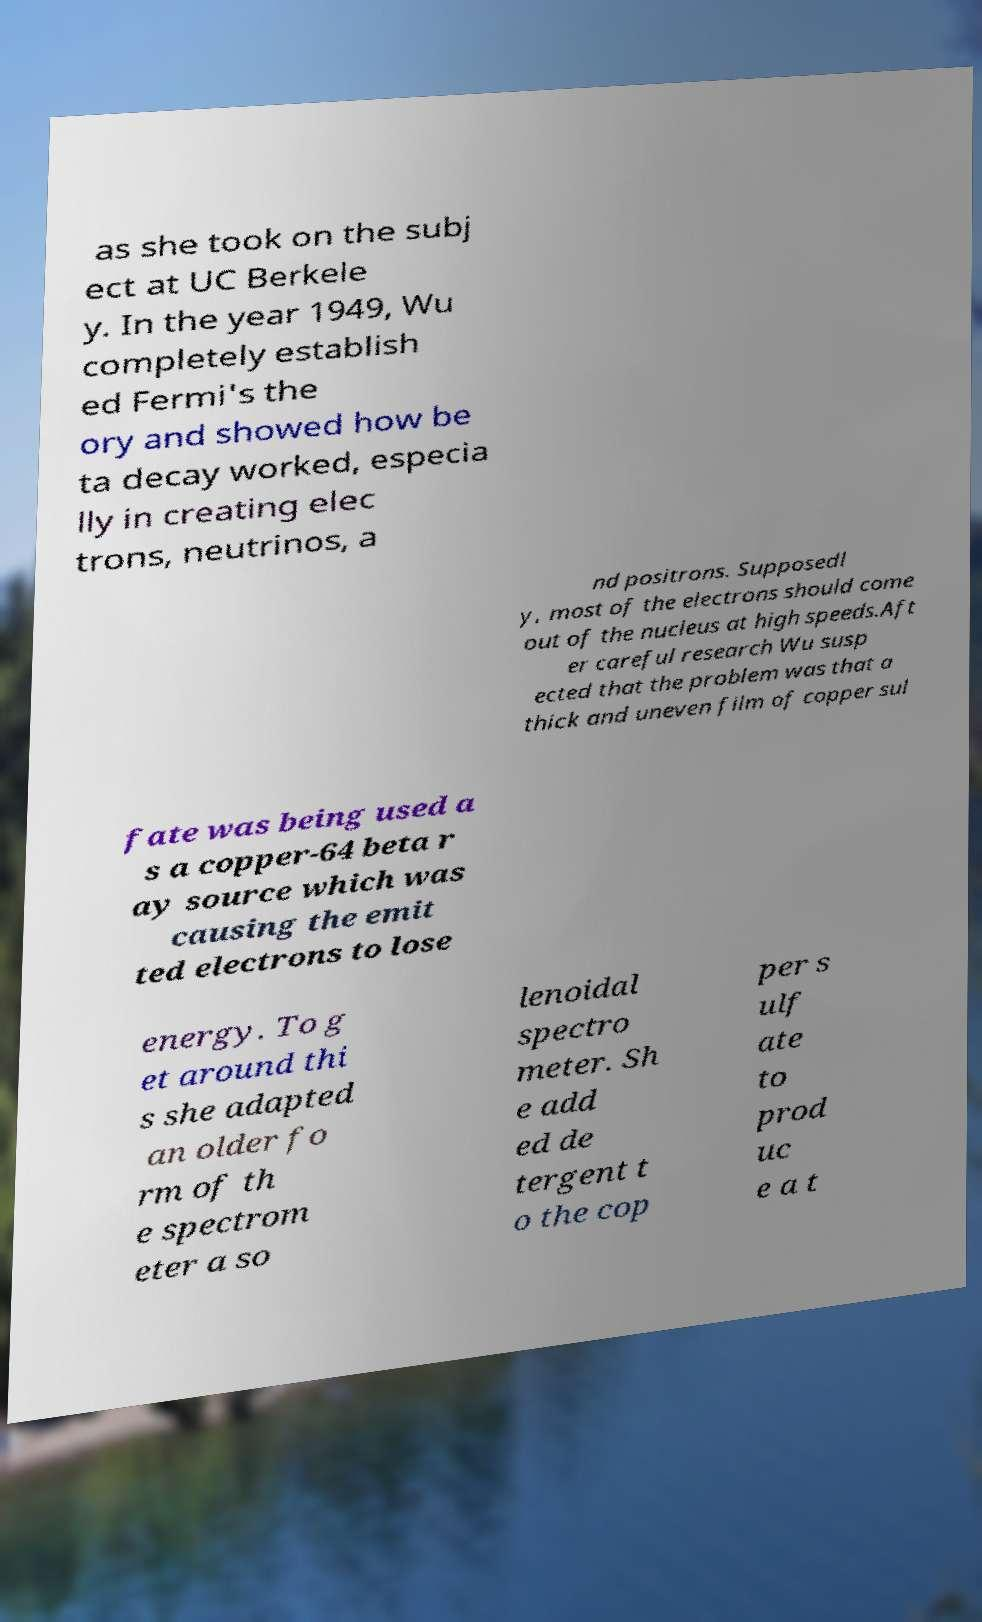Could you assist in decoding the text presented in this image and type it out clearly? as she took on the subj ect at UC Berkele y. In the year 1949, Wu completely establish ed Fermi's the ory and showed how be ta decay worked, especia lly in creating elec trons, neutrinos, a nd positrons. Supposedl y, most of the electrons should come out of the nucleus at high speeds.Aft er careful research Wu susp ected that the problem was that a thick and uneven film of copper sul fate was being used a s a copper-64 beta r ay source which was causing the emit ted electrons to lose energy. To g et around thi s she adapted an older fo rm of th e spectrom eter a so lenoidal spectro meter. Sh e add ed de tergent t o the cop per s ulf ate to prod uc e a t 